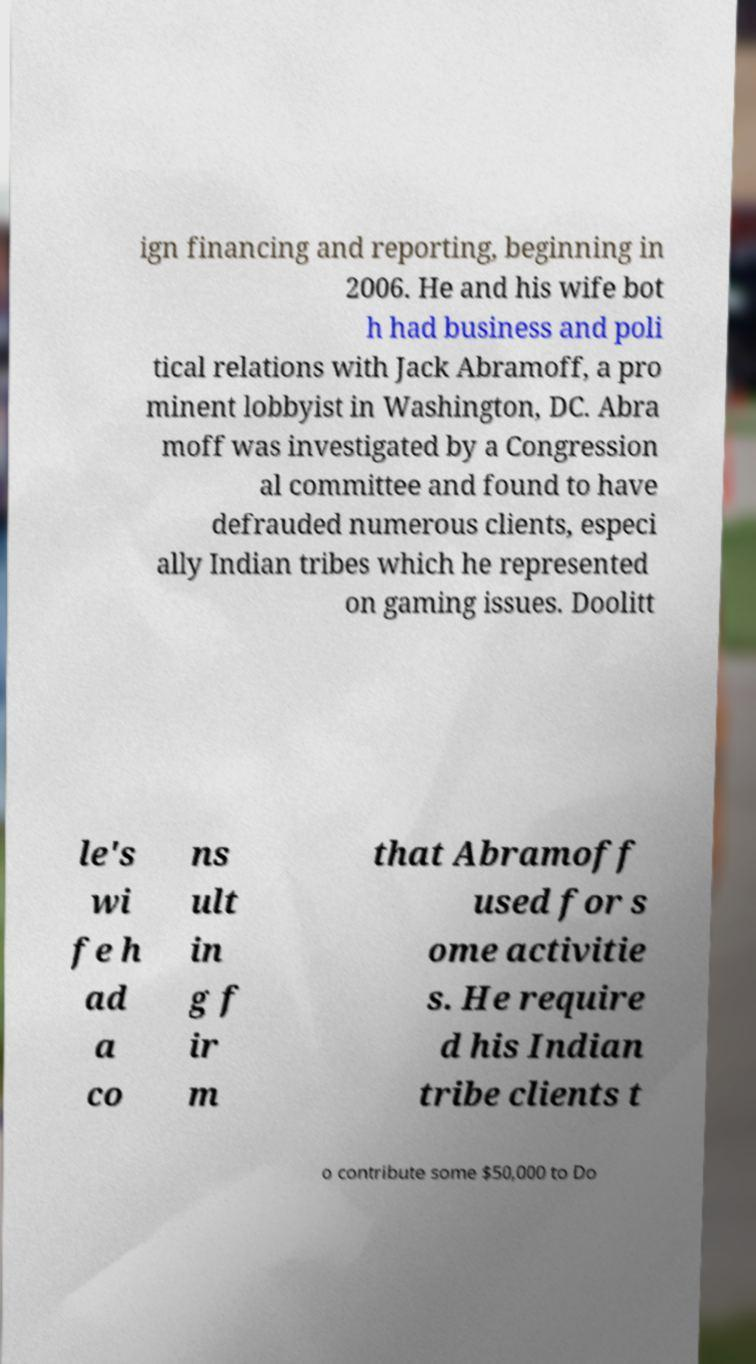There's text embedded in this image that I need extracted. Can you transcribe it verbatim? ign financing and reporting, beginning in 2006. He and his wife bot h had business and poli tical relations with Jack Abramoff, a pro minent lobbyist in Washington, DC. Abra moff was investigated by a Congression al committee and found to have defrauded numerous clients, especi ally Indian tribes which he represented on gaming issues. Doolitt le's wi fe h ad a co ns ult in g f ir m that Abramoff used for s ome activitie s. He require d his Indian tribe clients t o contribute some $50,000 to Do 